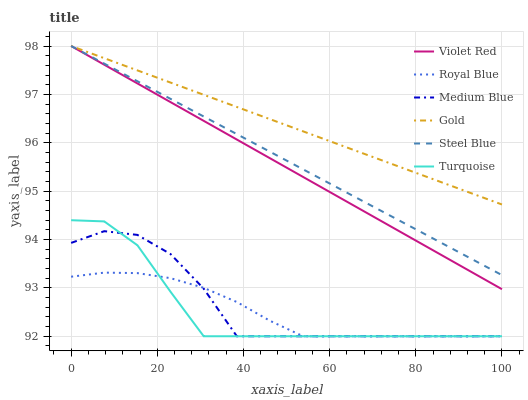Does Medium Blue have the minimum area under the curve?
Answer yes or no. No. Does Medium Blue have the maximum area under the curve?
Answer yes or no. No. Is Gold the smoothest?
Answer yes or no. No. Is Gold the roughest?
Answer yes or no. No. Does Gold have the lowest value?
Answer yes or no. No. Does Medium Blue have the highest value?
Answer yes or no. No. Is Medium Blue less than Violet Red?
Answer yes or no. Yes. Is Steel Blue greater than Medium Blue?
Answer yes or no. Yes. Does Medium Blue intersect Violet Red?
Answer yes or no. No. 